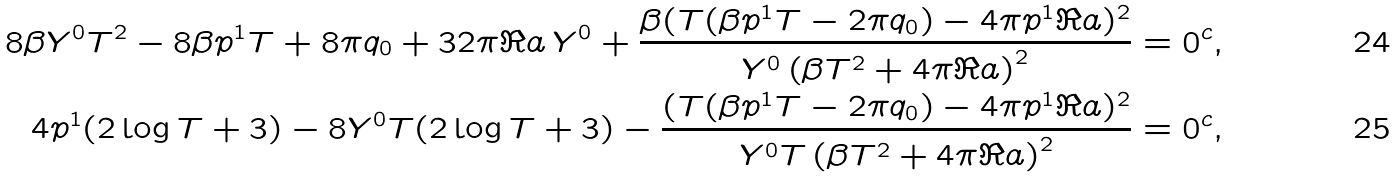<formula> <loc_0><loc_0><loc_500><loc_500>8 \beta Y ^ { 0 } T ^ { 2 } - 8 \beta p ^ { 1 } T + 8 \pi q _ { 0 } + 3 2 \pi \Re a \, Y ^ { 0 } + \frac { \beta ( T ( \beta p ^ { 1 } T - 2 \pi q _ { 0 } ) - 4 \pi p ^ { 1 } \Re a ) ^ { 2 } } { Y ^ { 0 } \left ( \beta T ^ { 2 } + 4 \pi \Re a \right ) ^ { 2 } } & = 0 ^ { c } , \\ 4 p ^ { 1 } ( 2 \log T + 3 ) - 8 Y ^ { 0 } T ( 2 \log T + 3 ) - \frac { ( T ( \beta p ^ { 1 } T - 2 \pi q _ { 0 } ) - 4 \pi p ^ { 1 } \Re a ) ^ { 2 } } { Y ^ { 0 } T \left ( \beta T ^ { 2 } + 4 \pi \Re a \right ) ^ { 2 } } & = 0 ^ { c } ,</formula> 